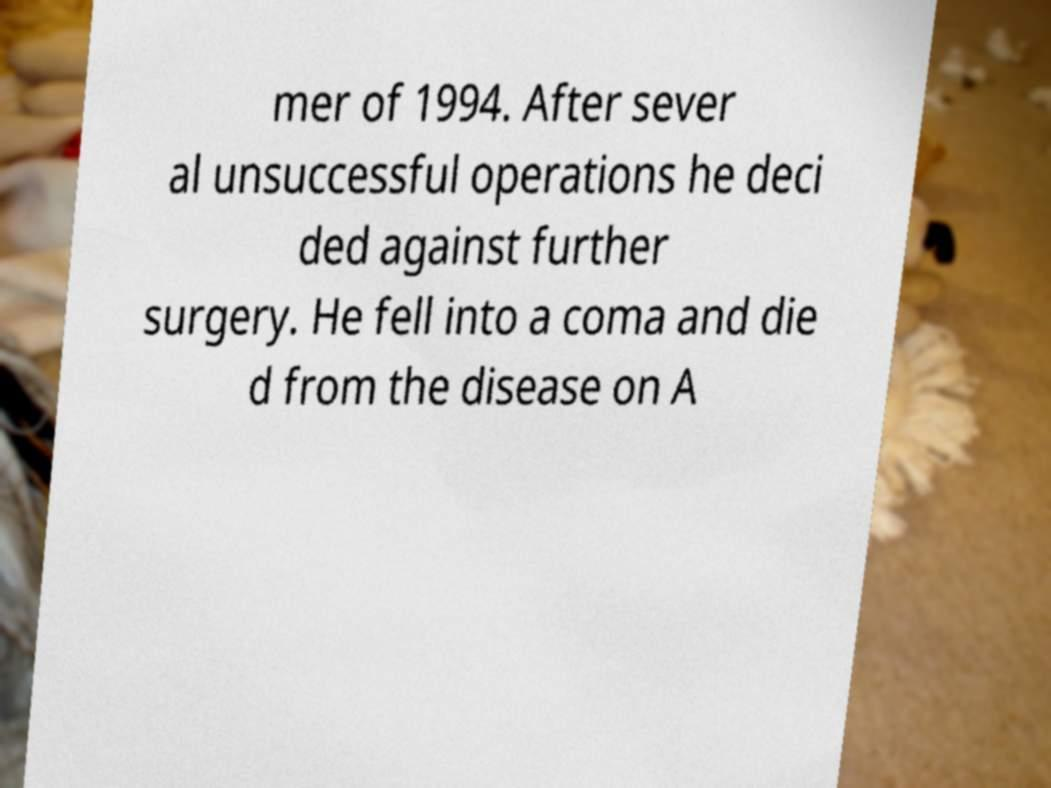There's text embedded in this image that I need extracted. Can you transcribe it verbatim? mer of 1994. After sever al unsuccessful operations he deci ded against further surgery. He fell into a coma and die d from the disease on A 